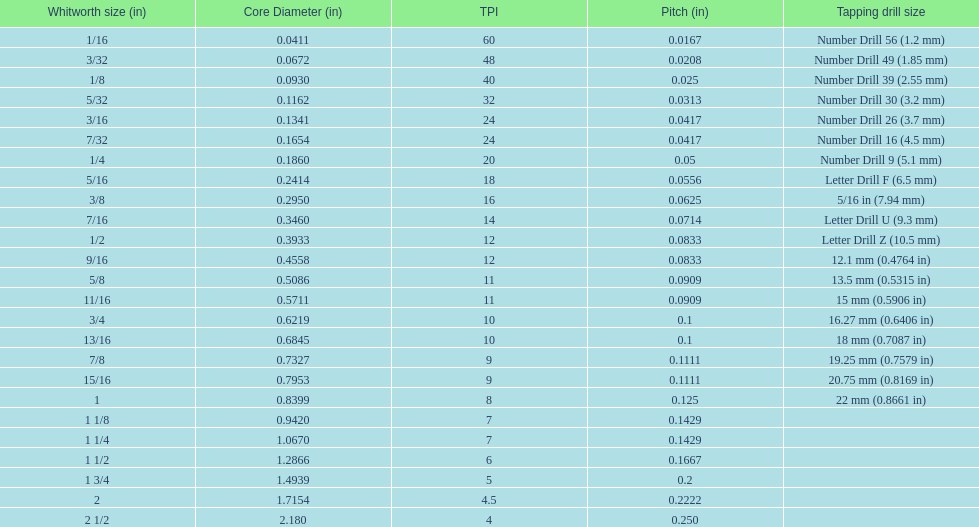In inches, what is the minimum core diameter? 0.0411. 